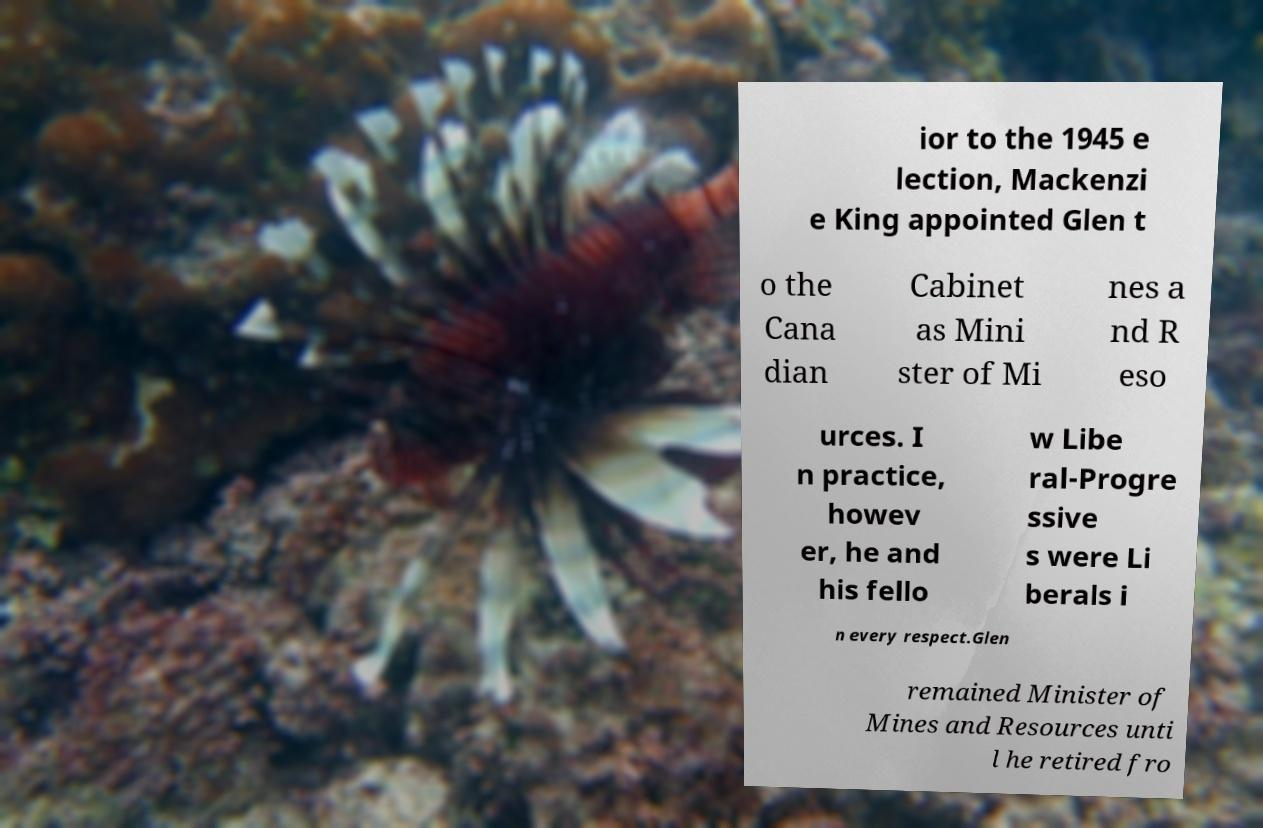Please identify and transcribe the text found in this image. ior to the 1945 e lection, Mackenzi e King appointed Glen t o the Cana dian Cabinet as Mini ster of Mi nes a nd R eso urces. I n practice, howev er, he and his fello w Libe ral-Progre ssive s were Li berals i n every respect.Glen remained Minister of Mines and Resources unti l he retired fro 